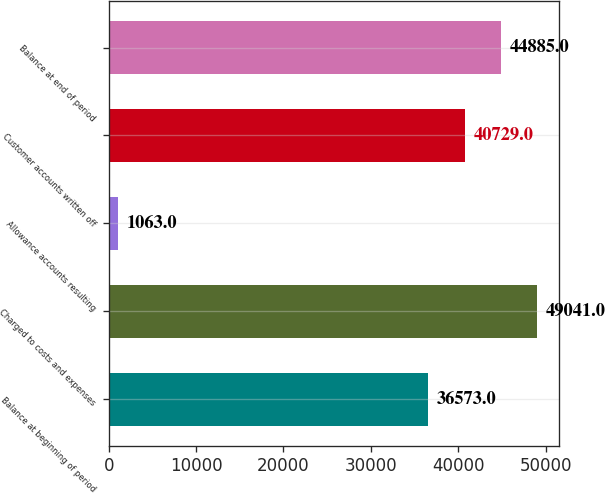Convert chart. <chart><loc_0><loc_0><loc_500><loc_500><bar_chart><fcel>Balance at beginning of period<fcel>Charged to costs and expenses<fcel>Allowance accounts resulting<fcel>Customer accounts written off<fcel>Balance at end of period<nl><fcel>36573<fcel>49041<fcel>1063<fcel>40729<fcel>44885<nl></chart> 